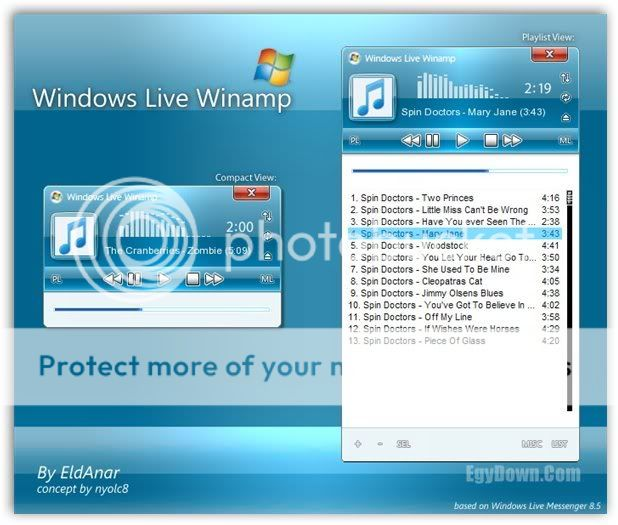Can you describe how the user interface design of the media player might influence user interaction? The user interface of the media player is designed with a clean, user-friendly layout that encourages intuitive navigation. The large playback control buttons are centrally located, making them easily accessible for basic user interactions such as play, pause, or stop. The volume control slider is prominently displayed at the bottom, allowing users to adjust the sound easily. The bright and contrasting colors used for highlighting active tracks or buttons help in quickly drawing the user's attention to current activities or selections. This design likely enhances the user experience by making the interaction straightforward and efficient. 